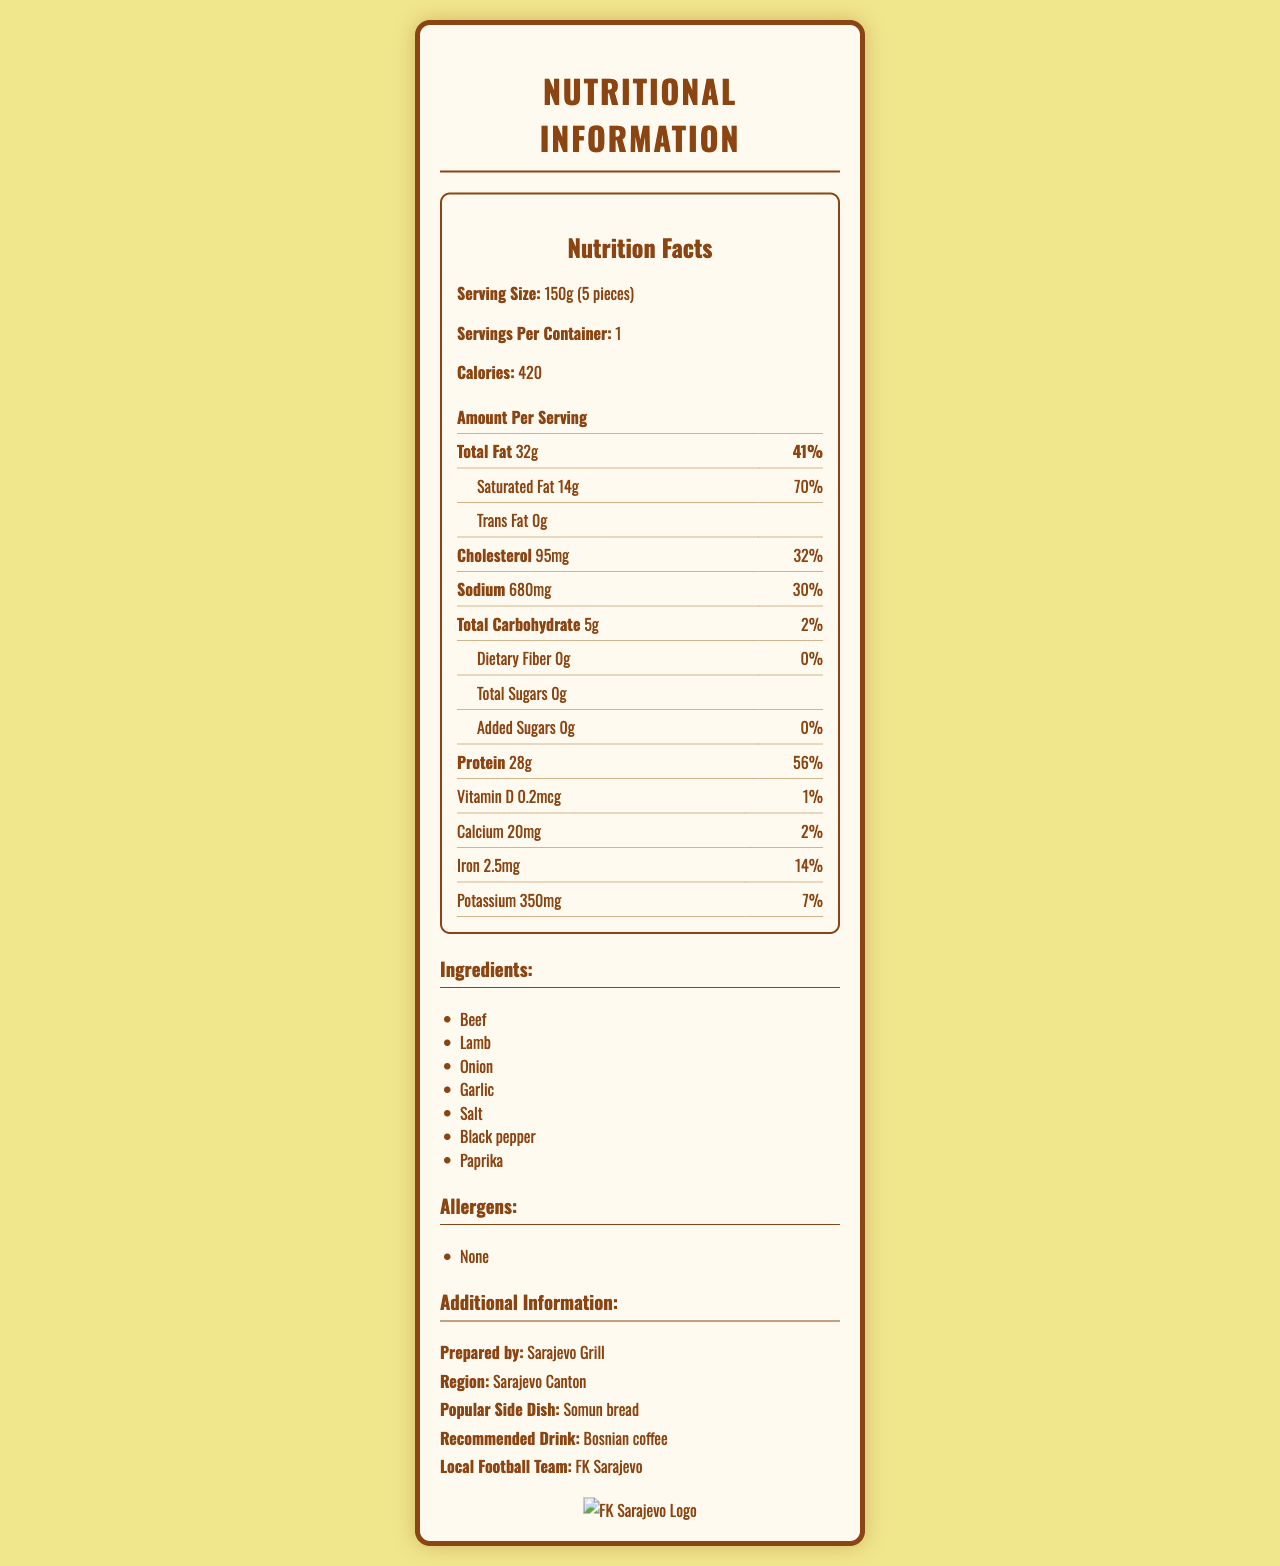what is the serving size of traditional Bosnian ćevapi? The serving size is listed at the top of the document under Nutrition Facts, with a value of 150g (5 pieces).
Answer: 150g (5 pieces) how many calories are there per serving of ćevapi? The calories per serving are listed right below the serving size and servings per container, indicating 420 calories per serving.
Answer: 420 calories what is the amount of saturated fat in one serving of ćevapi? In the nutrition facts table, under the total fat section, the amount of saturated fat is given as 14g.
Answer: 14g what is the percent daily value of protein in a serving? In the nutrition facts table, under the macronutrients section, the percent daily value for protein is listed as 56%.
Answer: 56% which ingredient is likely to be an allergen? The allergens section clearly states "None", indicating no common allergens are present in ćevapi.
Answer: None how much sodium is in one serving of ćevapi? The sodium content is directly listed in the nutrition facts under macronutrients with an amount of 680mg.
Answer: 680mg what is the amount of dietary fiber in ćevapi? Under the total carbohydrate section of the nutrition facts, the dietary fiber amount is listed as 0g.
Answer: 0g how much iron does one serving of ćevapi provide? The micronutrient section lists the amount of iron per serving as 2.5mg.
Answer: 2.5mg what is the preparation recommendation for ćevapi? A. Served with fries B. Served with Somun bread C. Served with salad D. Served with rice Under additional information, it mentions the popular side dish as "Somun bread".
Answer: B what vitamin is present in the smallest amount in ćevapi? A. Vitamin D B. Calcium C. Iron D. Potassium The micronutrient section shows that Vitamin D is present in the smallest amount at 0.2mcg.
Answer: A is there any trans fat in traditional Bosnian ćevapi? The nutrition facts table indicates that trans fat is 0g, implying there is no trans fat present.
Answer: No can I find the preparation date for ćevapi in this document? The document does not provide any information regarding the preparation date of the ćevapi.
Answer: Cannot be determined summarize the nutritional information for traditional Bosnian ćevapi provided in this document. This answer provides an overview of the key nutritional facts, ingredients, allergens, and additional information, summarizing the entire document.
Answer: Traditional Bosnian ćevapi (serving size 150g, 5 pieces) contains 420 calories per serving. It has 32g total fat (41% DV), 14g saturated fat (70% DV), 0g trans fat, 95mg cholesterol (32% DV), 680mg sodium (30% DV), 5g total carbohydrates (2% DV) with 0g dietary fiber and 0g total and added sugars, and 28g protein (56% DV). Micronutrients include 0.2mcg vitamin D (1% DV), 20mg calcium (2% DV), 2.5mg iron (14% DV), and 350mg potassium (7% DV). Ingredients include beef, lamb, onion, garlic, salt, black pepper, and paprika, with no listed allergens. Additional information mentions it is prepared by Sarajevo Grill, popular with Somun bread, and recommended to drink with Bosnian coffee, supporting football team FK Sarajevo. 